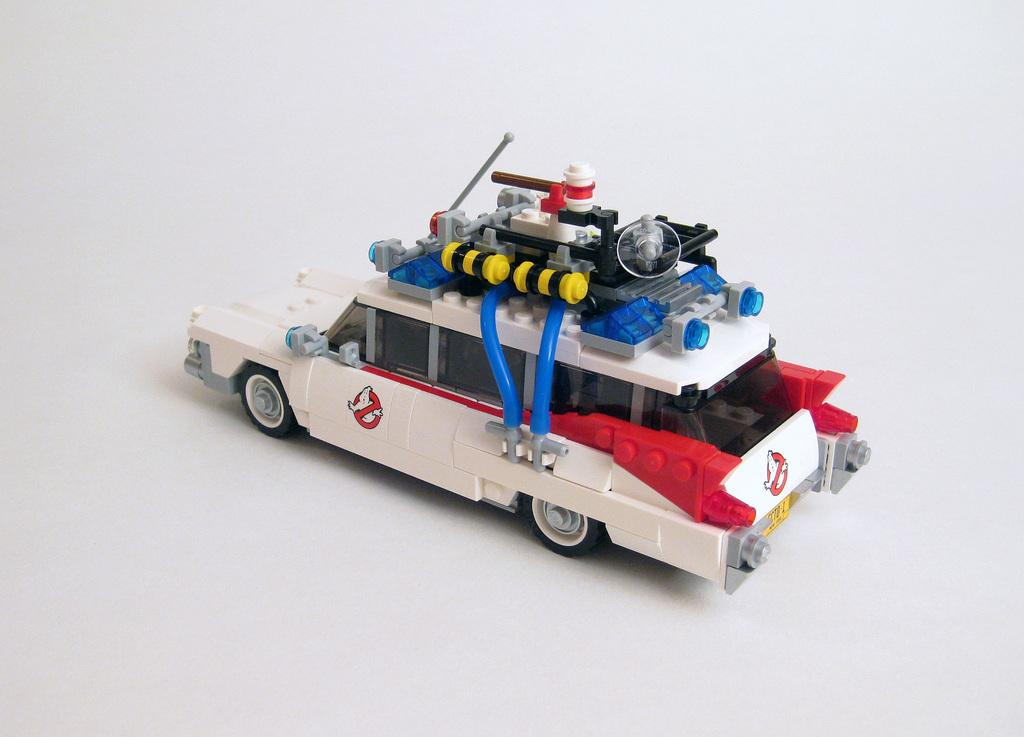What is the main object in the image? There is a toy vehicle in the image. What is the toy vehicle placed on? The toy vehicle is on a white platform. What type of vegetable is being used as a ramp for the toy vehicle in the image? There is no vegetable present in the image, and the toy vehicle is not on a ramp. 